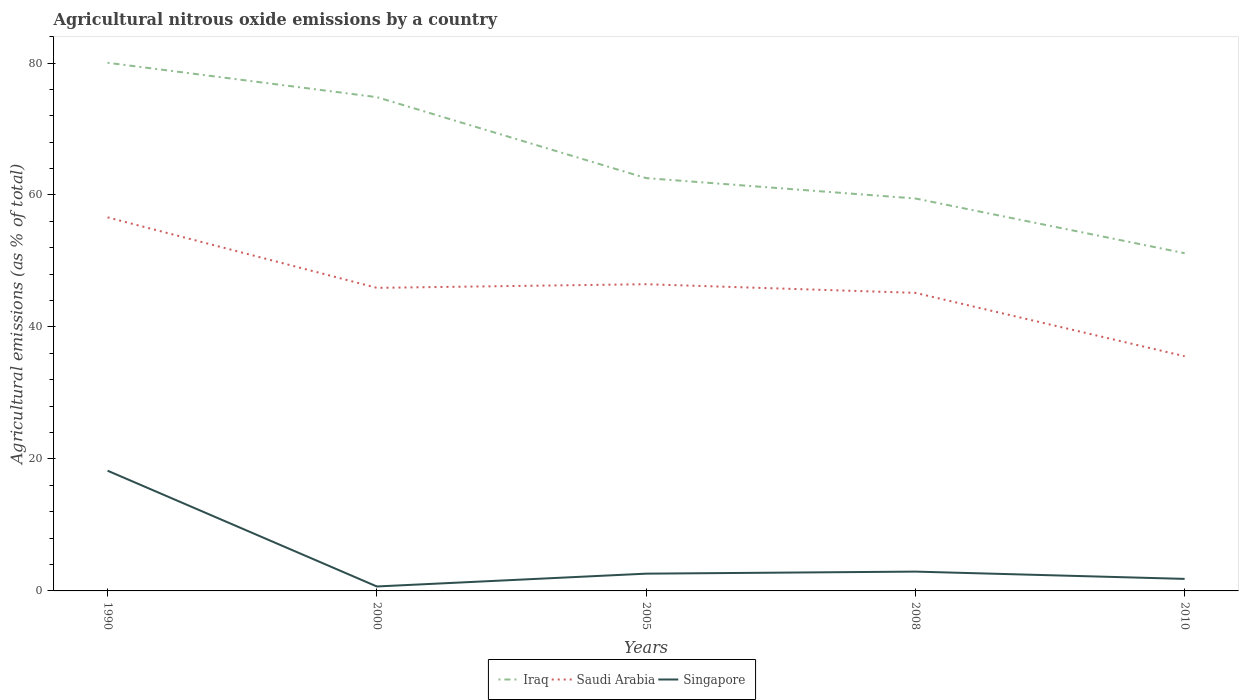How many different coloured lines are there?
Give a very brief answer. 3. Does the line corresponding to Iraq intersect with the line corresponding to Singapore?
Your answer should be very brief. No. Is the number of lines equal to the number of legend labels?
Make the answer very short. Yes. Across all years, what is the maximum amount of agricultural nitrous oxide emitted in Iraq?
Make the answer very short. 51.18. In which year was the amount of agricultural nitrous oxide emitted in Singapore maximum?
Provide a short and direct response. 2000. What is the total amount of agricultural nitrous oxide emitted in Iraq in the graph?
Keep it short and to the point. 5.21. What is the difference between the highest and the second highest amount of agricultural nitrous oxide emitted in Singapore?
Ensure brevity in your answer.  17.55. How many years are there in the graph?
Make the answer very short. 5. Does the graph contain any zero values?
Offer a terse response. No. Where does the legend appear in the graph?
Offer a terse response. Bottom center. What is the title of the graph?
Your answer should be very brief. Agricultural nitrous oxide emissions by a country. Does "Zimbabwe" appear as one of the legend labels in the graph?
Make the answer very short. No. What is the label or title of the X-axis?
Give a very brief answer. Years. What is the label or title of the Y-axis?
Provide a succinct answer. Agricultural emissions (as % of total). What is the Agricultural emissions (as % of total) in Iraq in 1990?
Offer a terse response. 80.04. What is the Agricultural emissions (as % of total) of Saudi Arabia in 1990?
Your answer should be very brief. 56.61. What is the Agricultural emissions (as % of total) of Singapore in 1990?
Make the answer very short. 18.22. What is the Agricultural emissions (as % of total) of Iraq in 2000?
Make the answer very short. 74.83. What is the Agricultural emissions (as % of total) of Saudi Arabia in 2000?
Your answer should be very brief. 45.93. What is the Agricultural emissions (as % of total) of Singapore in 2000?
Offer a terse response. 0.67. What is the Agricultural emissions (as % of total) in Iraq in 2005?
Ensure brevity in your answer.  62.56. What is the Agricultural emissions (as % of total) of Saudi Arabia in 2005?
Provide a short and direct response. 46.48. What is the Agricultural emissions (as % of total) in Singapore in 2005?
Offer a very short reply. 2.62. What is the Agricultural emissions (as % of total) of Iraq in 2008?
Your answer should be compact. 59.47. What is the Agricultural emissions (as % of total) in Saudi Arabia in 2008?
Provide a succinct answer. 45.17. What is the Agricultural emissions (as % of total) of Singapore in 2008?
Give a very brief answer. 2.93. What is the Agricultural emissions (as % of total) in Iraq in 2010?
Your answer should be compact. 51.18. What is the Agricultural emissions (as % of total) in Saudi Arabia in 2010?
Keep it short and to the point. 35.57. What is the Agricultural emissions (as % of total) of Singapore in 2010?
Offer a terse response. 1.82. Across all years, what is the maximum Agricultural emissions (as % of total) of Iraq?
Provide a succinct answer. 80.04. Across all years, what is the maximum Agricultural emissions (as % of total) in Saudi Arabia?
Give a very brief answer. 56.61. Across all years, what is the maximum Agricultural emissions (as % of total) of Singapore?
Keep it short and to the point. 18.22. Across all years, what is the minimum Agricultural emissions (as % of total) of Iraq?
Make the answer very short. 51.18. Across all years, what is the minimum Agricultural emissions (as % of total) in Saudi Arabia?
Make the answer very short. 35.57. Across all years, what is the minimum Agricultural emissions (as % of total) of Singapore?
Offer a terse response. 0.67. What is the total Agricultural emissions (as % of total) in Iraq in the graph?
Provide a short and direct response. 328.08. What is the total Agricultural emissions (as % of total) in Saudi Arabia in the graph?
Offer a very short reply. 229.76. What is the total Agricultural emissions (as % of total) in Singapore in the graph?
Provide a short and direct response. 26.26. What is the difference between the Agricultural emissions (as % of total) in Iraq in 1990 and that in 2000?
Give a very brief answer. 5.21. What is the difference between the Agricultural emissions (as % of total) of Saudi Arabia in 1990 and that in 2000?
Offer a very short reply. 10.68. What is the difference between the Agricultural emissions (as % of total) of Singapore in 1990 and that in 2000?
Offer a terse response. 17.55. What is the difference between the Agricultural emissions (as % of total) in Iraq in 1990 and that in 2005?
Make the answer very short. 17.48. What is the difference between the Agricultural emissions (as % of total) of Saudi Arabia in 1990 and that in 2005?
Make the answer very short. 10.13. What is the difference between the Agricultural emissions (as % of total) of Singapore in 1990 and that in 2005?
Offer a terse response. 15.6. What is the difference between the Agricultural emissions (as % of total) of Iraq in 1990 and that in 2008?
Offer a terse response. 20.57. What is the difference between the Agricultural emissions (as % of total) in Saudi Arabia in 1990 and that in 2008?
Your answer should be very brief. 11.44. What is the difference between the Agricultural emissions (as % of total) of Singapore in 1990 and that in 2008?
Give a very brief answer. 15.29. What is the difference between the Agricultural emissions (as % of total) in Iraq in 1990 and that in 2010?
Give a very brief answer. 28.86. What is the difference between the Agricultural emissions (as % of total) in Saudi Arabia in 1990 and that in 2010?
Your answer should be very brief. 21.04. What is the difference between the Agricultural emissions (as % of total) in Singapore in 1990 and that in 2010?
Your answer should be compact. 16.4. What is the difference between the Agricultural emissions (as % of total) of Iraq in 2000 and that in 2005?
Provide a short and direct response. 12.27. What is the difference between the Agricultural emissions (as % of total) of Saudi Arabia in 2000 and that in 2005?
Offer a very short reply. -0.55. What is the difference between the Agricultural emissions (as % of total) in Singapore in 2000 and that in 2005?
Your response must be concise. -1.94. What is the difference between the Agricultural emissions (as % of total) of Iraq in 2000 and that in 2008?
Make the answer very short. 15.36. What is the difference between the Agricultural emissions (as % of total) in Saudi Arabia in 2000 and that in 2008?
Offer a very short reply. 0.76. What is the difference between the Agricultural emissions (as % of total) of Singapore in 2000 and that in 2008?
Your response must be concise. -2.25. What is the difference between the Agricultural emissions (as % of total) in Iraq in 2000 and that in 2010?
Offer a terse response. 23.65. What is the difference between the Agricultural emissions (as % of total) in Saudi Arabia in 2000 and that in 2010?
Offer a terse response. 10.36. What is the difference between the Agricultural emissions (as % of total) in Singapore in 2000 and that in 2010?
Your answer should be compact. -1.15. What is the difference between the Agricultural emissions (as % of total) in Iraq in 2005 and that in 2008?
Your answer should be very brief. 3.09. What is the difference between the Agricultural emissions (as % of total) of Saudi Arabia in 2005 and that in 2008?
Provide a short and direct response. 1.31. What is the difference between the Agricultural emissions (as % of total) in Singapore in 2005 and that in 2008?
Your answer should be very brief. -0.31. What is the difference between the Agricultural emissions (as % of total) in Iraq in 2005 and that in 2010?
Your answer should be compact. 11.38. What is the difference between the Agricultural emissions (as % of total) of Saudi Arabia in 2005 and that in 2010?
Offer a very short reply. 10.91. What is the difference between the Agricultural emissions (as % of total) of Singapore in 2005 and that in 2010?
Ensure brevity in your answer.  0.79. What is the difference between the Agricultural emissions (as % of total) of Iraq in 2008 and that in 2010?
Ensure brevity in your answer.  8.29. What is the difference between the Agricultural emissions (as % of total) in Saudi Arabia in 2008 and that in 2010?
Provide a short and direct response. 9.6. What is the difference between the Agricultural emissions (as % of total) in Singapore in 2008 and that in 2010?
Give a very brief answer. 1.11. What is the difference between the Agricultural emissions (as % of total) in Iraq in 1990 and the Agricultural emissions (as % of total) in Saudi Arabia in 2000?
Offer a very short reply. 34.11. What is the difference between the Agricultural emissions (as % of total) of Iraq in 1990 and the Agricultural emissions (as % of total) of Singapore in 2000?
Your answer should be compact. 79.36. What is the difference between the Agricultural emissions (as % of total) of Saudi Arabia in 1990 and the Agricultural emissions (as % of total) of Singapore in 2000?
Make the answer very short. 55.94. What is the difference between the Agricultural emissions (as % of total) in Iraq in 1990 and the Agricultural emissions (as % of total) in Saudi Arabia in 2005?
Provide a short and direct response. 33.56. What is the difference between the Agricultural emissions (as % of total) of Iraq in 1990 and the Agricultural emissions (as % of total) of Singapore in 2005?
Give a very brief answer. 77.42. What is the difference between the Agricultural emissions (as % of total) of Saudi Arabia in 1990 and the Agricultural emissions (as % of total) of Singapore in 2005?
Offer a terse response. 53.99. What is the difference between the Agricultural emissions (as % of total) in Iraq in 1990 and the Agricultural emissions (as % of total) in Saudi Arabia in 2008?
Make the answer very short. 34.87. What is the difference between the Agricultural emissions (as % of total) in Iraq in 1990 and the Agricultural emissions (as % of total) in Singapore in 2008?
Make the answer very short. 77.11. What is the difference between the Agricultural emissions (as % of total) in Saudi Arabia in 1990 and the Agricultural emissions (as % of total) in Singapore in 2008?
Your response must be concise. 53.68. What is the difference between the Agricultural emissions (as % of total) of Iraq in 1990 and the Agricultural emissions (as % of total) of Saudi Arabia in 2010?
Make the answer very short. 44.47. What is the difference between the Agricultural emissions (as % of total) of Iraq in 1990 and the Agricultural emissions (as % of total) of Singapore in 2010?
Provide a short and direct response. 78.22. What is the difference between the Agricultural emissions (as % of total) in Saudi Arabia in 1990 and the Agricultural emissions (as % of total) in Singapore in 2010?
Your response must be concise. 54.79. What is the difference between the Agricultural emissions (as % of total) of Iraq in 2000 and the Agricultural emissions (as % of total) of Saudi Arabia in 2005?
Your answer should be compact. 28.35. What is the difference between the Agricultural emissions (as % of total) in Iraq in 2000 and the Agricultural emissions (as % of total) in Singapore in 2005?
Offer a very short reply. 72.21. What is the difference between the Agricultural emissions (as % of total) in Saudi Arabia in 2000 and the Agricultural emissions (as % of total) in Singapore in 2005?
Provide a succinct answer. 43.31. What is the difference between the Agricultural emissions (as % of total) in Iraq in 2000 and the Agricultural emissions (as % of total) in Saudi Arabia in 2008?
Your answer should be compact. 29.66. What is the difference between the Agricultural emissions (as % of total) in Iraq in 2000 and the Agricultural emissions (as % of total) in Singapore in 2008?
Your response must be concise. 71.9. What is the difference between the Agricultural emissions (as % of total) in Saudi Arabia in 2000 and the Agricultural emissions (as % of total) in Singapore in 2008?
Keep it short and to the point. 43. What is the difference between the Agricultural emissions (as % of total) of Iraq in 2000 and the Agricultural emissions (as % of total) of Saudi Arabia in 2010?
Give a very brief answer. 39.26. What is the difference between the Agricultural emissions (as % of total) in Iraq in 2000 and the Agricultural emissions (as % of total) in Singapore in 2010?
Offer a very short reply. 73.01. What is the difference between the Agricultural emissions (as % of total) in Saudi Arabia in 2000 and the Agricultural emissions (as % of total) in Singapore in 2010?
Offer a terse response. 44.11. What is the difference between the Agricultural emissions (as % of total) of Iraq in 2005 and the Agricultural emissions (as % of total) of Saudi Arabia in 2008?
Ensure brevity in your answer.  17.39. What is the difference between the Agricultural emissions (as % of total) of Iraq in 2005 and the Agricultural emissions (as % of total) of Singapore in 2008?
Keep it short and to the point. 59.63. What is the difference between the Agricultural emissions (as % of total) of Saudi Arabia in 2005 and the Agricultural emissions (as % of total) of Singapore in 2008?
Offer a very short reply. 43.55. What is the difference between the Agricultural emissions (as % of total) in Iraq in 2005 and the Agricultural emissions (as % of total) in Saudi Arabia in 2010?
Provide a succinct answer. 26.99. What is the difference between the Agricultural emissions (as % of total) in Iraq in 2005 and the Agricultural emissions (as % of total) in Singapore in 2010?
Keep it short and to the point. 60.74. What is the difference between the Agricultural emissions (as % of total) in Saudi Arabia in 2005 and the Agricultural emissions (as % of total) in Singapore in 2010?
Keep it short and to the point. 44.66. What is the difference between the Agricultural emissions (as % of total) of Iraq in 2008 and the Agricultural emissions (as % of total) of Saudi Arabia in 2010?
Your response must be concise. 23.9. What is the difference between the Agricultural emissions (as % of total) in Iraq in 2008 and the Agricultural emissions (as % of total) in Singapore in 2010?
Ensure brevity in your answer.  57.65. What is the difference between the Agricultural emissions (as % of total) in Saudi Arabia in 2008 and the Agricultural emissions (as % of total) in Singapore in 2010?
Offer a terse response. 43.35. What is the average Agricultural emissions (as % of total) in Iraq per year?
Make the answer very short. 65.62. What is the average Agricultural emissions (as % of total) of Saudi Arabia per year?
Give a very brief answer. 45.95. What is the average Agricultural emissions (as % of total) in Singapore per year?
Your answer should be compact. 5.25. In the year 1990, what is the difference between the Agricultural emissions (as % of total) of Iraq and Agricultural emissions (as % of total) of Saudi Arabia?
Offer a terse response. 23.43. In the year 1990, what is the difference between the Agricultural emissions (as % of total) of Iraq and Agricultural emissions (as % of total) of Singapore?
Give a very brief answer. 61.82. In the year 1990, what is the difference between the Agricultural emissions (as % of total) in Saudi Arabia and Agricultural emissions (as % of total) in Singapore?
Offer a terse response. 38.39. In the year 2000, what is the difference between the Agricultural emissions (as % of total) in Iraq and Agricultural emissions (as % of total) in Saudi Arabia?
Provide a succinct answer. 28.9. In the year 2000, what is the difference between the Agricultural emissions (as % of total) in Iraq and Agricultural emissions (as % of total) in Singapore?
Offer a terse response. 74.15. In the year 2000, what is the difference between the Agricultural emissions (as % of total) in Saudi Arabia and Agricultural emissions (as % of total) in Singapore?
Your response must be concise. 45.25. In the year 2005, what is the difference between the Agricultural emissions (as % of total) in Iraq and Agricultural emissions (as % of total) in Saudi Arabia?
Your answer should be very brief. 16.08. In the year 2005, what is the difference between the Agricultural emissions (as % of total) of Iraq and Agricultural emissions (as % of total) of Singapore?
Provide a succinct answer. 59.94. In the year 2005, what is the difference between the Agricultural emissions (as % of total) of Saudi Arabia and Agricultural emissions (as % of total) of Singapore?
Your answer should be compact. 43.86. In the year 2008, what is the difference between the Agricultural emissions (as % of total) in Iraq and Agricultural emissions (as % of total) in Saudi Arabia?
Keep it short and to the point. 14.3. In the year 2008, what is the difference between the Agricultural emissions (as % of total) in Iraq and Agricultural emissions (as % of total) in Singapore?
Provide a succinct answer. 56.54. In the year 2008, what is the difference between the Agricultural emissions (as % of total) of Saudi Arabia and Agricultural emissions (as % of total) of Singapore?
Offer a very short reply. 42.24. In the year 2010, what is the difference between the Agricultural emissions (as % of total) in Iraq and Agricultural emissions (as % of total) in Saudi Arabia?
Offer a terse response. 15.61. In the year 2010, what is the difference between the Agricultural emissions (as % of total) of Iraq and Agricultural emissions (as % of total) of Singapore?
Offer a very short reply. 49.36. In the year 2010, what is the difference between the Agricultural emissions (as % of total) in Saudi Arabia and Agricultural emissions (as % of total) in Singapore?
Ensure brevity in your answer.  33.75. What is the ratio of the Agricultural emissions (as % of total) in Iraq in 1990 to that in 2000?
Your answer should be very brief. 1.07. What is the ratio of the Agricultural emissions (as % of total) in Saudi Arabia in 1990 to that in 2000?
Keep it short and to the point. 1.23. What is the ratio of the Agricultural emissions (as % of total) in Singapore in 1990 to that in 2000?
Your answer should be very brief. 27.02. What is the ratio of the Agricultural emissions (as % of total) in Iraq in 1990 to that in 2005?
Offer a terse response. 1.28. What is the ratio of the Agricultural emissions (as % of total) in Saudi Arabia in 1990 to that in 2005?
Ensure brevity in your answer.  1.22. What is the ratio of the Agricultural emissions (as % of total) of Singapore in 1990 to that in 2005?
Keep it short and to the point. 6.96. What is the ratio of the Agricultural emissions (as % of total) of Iraq in 1990 to that in 2008?
Provide a succinct answer. 1.35. What is the ratio of the Agricultural emissions (as % of total) in Saudi Arabia in 1990 to that in 2008?
Give a very brief answer. 1.25. What is the ratio of the Agricultural emissions (as % of total) in Singapore in 1990 to that in 2008?
Keep it short and to the point. 6.22. What is the ratio of the Agricultural emissions (as % of total) in Iraq in 1990 to that in 2010?
Offer a very short reply. 1.56. What is the ratio of the Agricultural emissions (as % of total) of Saudi Arabia in 1990 to that in 2010?
Your response must be concise. 1.59. What is the ratio of the Agricultural emissions (as % of total) of Singapore in 1990 to that in 2010?
Keep it short and to the point. 10. What is the ratio of the Agricultural emissions (as % of total) in Iraq in 2000 to that in 2005?
Give a very brief answer. 1.2. What is the ratio of the Agricultural emissions (as % of total) in Singapore in 2000 to that in 2005?
Your response must be concise. 0.26. What is the ratio of the Agricultural emissions (as % of total) in Iraq in 2000 to that in 2008?
Offer a very short reply. 1.26. What is the ratio of the Agricultural emissions (as % of total) in Saudi Arabia in 2000 to that in 2008?
Offer a very short reply. 1.02. What is the ratio of the Agricultural emissions (as % of total) in Singapore in 2000 to that in 2008?
Offer a very short reply. 0.23. What is the ratio of the Agricultural emissions (as % of total) in Iraq in 2000 to that in 2010?
Provide a succinct answer. 1.46. What is the ratio of the Agricultural emissions (as % of total) in Saudi Arabia in 2000 to that in 2010?
Your answer should be very brief. 1.29. What is the ratio of the Agricultural emissions (as % of total) in Singapore in 2000 to that in 2010?
Make the answer very short. 0.37. What is the ratio of the Agricultural emissions (as % of total) of Iraq in 2005 to that in 2008?
Your response must be concise. 1.05. What is the ratio of the Agricultural emissions (as % of total) in Singapore in 2005 to that in 2008?
Keep it short and to the point. 0.89. What is the ratio of the Agricultural emissions (as % of total) in Iraq in 2005 to that in 2010?
Make the answer very short. 1.22. What is the ratio of the Agricultural emissions (as % of total) of Saudi Arabia in 2005 to that in 2010?
Your answer should be compact. 1.31. What is the ratio of the Agricultural emissions (as % of total) of Singapore in 2005 to that in 2010?
Your response must be concise. 1.44. What is the ratio of the Agricultural emissions (as % of total) of Iraq in 2008 to that in 2010?
Give a very brief answer. 1.16. What is the ratio of the Agricultural emissions (as % of total) of Saudi Arabia in 2008 to that in 2010?
Offer a terse response. 1.27. What is the ratio of the Agricultural emissions (as % of total) of Singapore in 2008 to that in 2010?
Your answer should be very brief. 1.61. What is the difference between the highest and the second highest Agricultural emissions (as % of total) in Iraq?
Offer a terse response. 5.21. What is the difference between the highest and the second highest Agricultural emissions (as % of total) of Saudi Arabia?
Your answer should be very brief. 10.13. What is the difference between the highest and the second highest Agricultural emissions (as % of total) in Singapore?
Offer a very short reply. 15.29. What is the difference between the highest and the lowest Agricultural emissions (as % of total) of Iraq?
Offer a very short reply. 28.86. What is the difference between the highest and the lowest Agricultural emissions (as % of total) in Saudi Arabia?
Provide a short and direct response. 21.04. What is the difference between the highest and the lowest Agricultural emissions (as % of total) of Singapore?
Your answer should be compact. 17.55. 